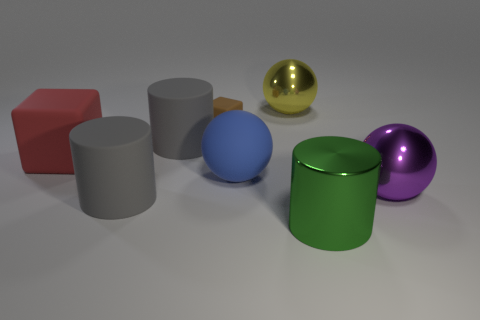Does the big shiny cylinder have the same color as the big matte ball?
Your response must be concise. No. How many things are either things that are behind the big blue matte thing or blue rubber balls?
Offer a terse response. 5. What number of big red things are right of the gray matte cylinder behind the big sphere right of the large yellow thing?
Make the answer very short. 0. Is there anything else that is the same size as the purple shiny sphere?
Provide a succinct answer. Yes. The gray thing that is behind the sphere to the right of the large cylinder that is right of the big yellow thing is what shape?
Give a very brief answer. Cylinder. What number of other objects are there of the same color as the small thing?
Provide a short and direct response. 0. There is a large gray rubber thing on the left side of the big gray rubber cylinder behind the big red block; what shape is it?
Keep it short and to the point. Cylinder. How many large purple spheres are left of the large yellow sphere?
Offer a very short reply. 0. Is there another red cube that has the same material as the red block?
Your answer should be very brief. No. There is a yellow object that is the same size as the purple shiny sphere; what material is it?
Offer a very short reply. Metal. 